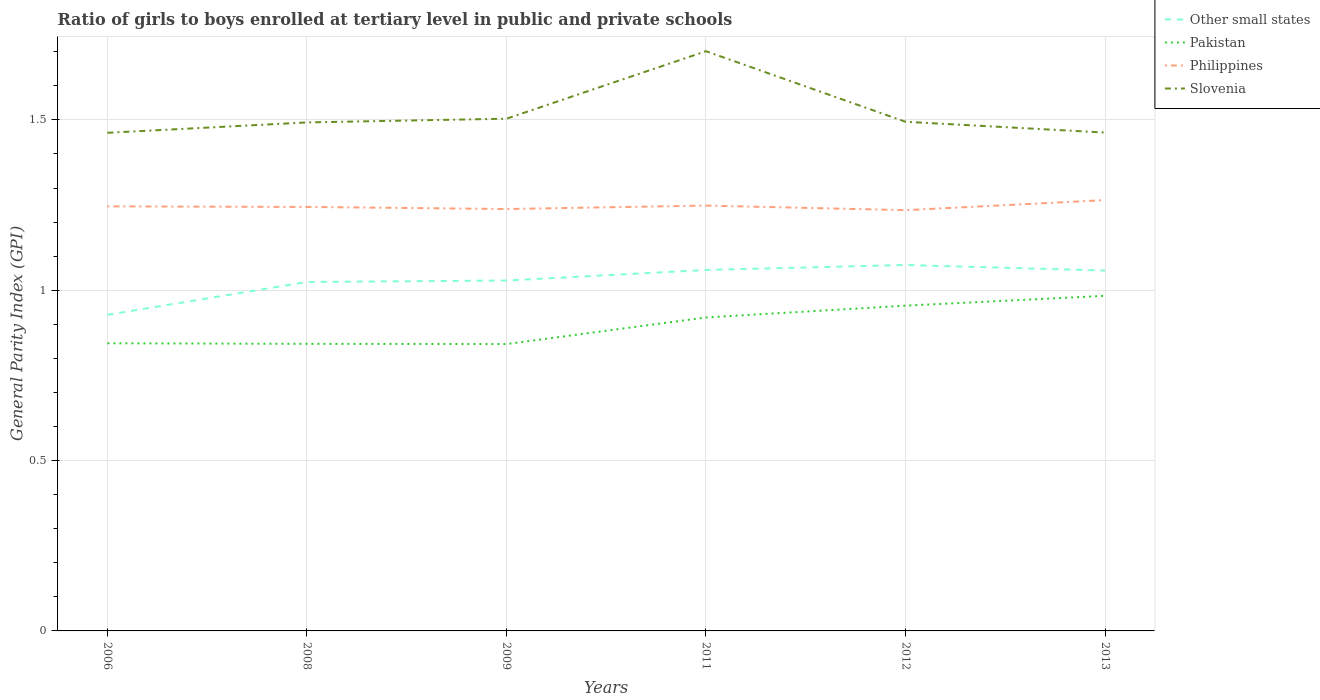How many different coloured lines are there?
Keep it short and to the point. 4. Does the line corresponding to Philippines intersect with the line corresponding to Other small states?
Keep it short and to the point. No. Is the number of lines equal to the number of legend labels?
Make the answer very short. Yes. Across all years, what is the maximum general parity index in Philippines?
Ensure brevity in your answer.  1.24. What is the total general parity index in Other small states in the graph?
Ensure brevity in your answer.  -0.15. What is the difference between the highest and the second highest general parity index in Other small states?
Provide a succinct answer. 0.15. Is the general parity index in Slovenia strictly greater than the general parity index in Philippines over the years?
Make the answer very short. No. How many lines are there?
Keep it short and to the point. 4. How many years are there in the graph?
Provide a short and direct response. 6. Are the values on the major ticks of Y-axis written in scientific E-notation?
Ensure brevity in your answer.  No. Where does the legend appear in the graph?
Keep it short and to the point. Top right. How many legend labels are there?
Provide a short and direct response. 4. What is the title of the graph?
Offer a very short reply. Ratio of girls to boys enrolled at tertiary level in public and private schools. What is the label or title of the X-axis?
Give a very brief answer. Years. What is the label or title of the Y-axis?
Make the answer very short. General Parity Index (GPI). What is the General Parity Index (GPI) of Other small states in 2006?
Your answer should be very brief. 0.93. What is the General Parity Index (GPI) of Pakistan in 2006?
Provide a short and direct response. 0.84. What is the General Parity Index (GPI) of Philippines in 2006?
Offer a terse response. 1.25. What is the General Parity Index (GPI) of Slovenia in 2006?
Your response must be concise. 1.46. What is the General Parity Index (GPI) of Other small states in 2008?
Offer a terse response. 1.02. What is the General Parity Index (GPI) in Pakistan in 2008?
Provide a succinct answer. 0.84. What is the General Parity Index (GPI) of Philippines in 2008?
Your response must be concise. 1.24. What is the General Parity Index (GPI) of Slovenia in 2008?
Provide a succinct answer. 1.49. What is the General Parity Index (GPI) in Other small states in 2009?
Give a very brief answer. 1.03. What is the General Parity Index (GPI) in Pakistan in 2009?
Keep it short and to the point. 0.84. What is the General Parity Index (GPI) in Philippines in 2009?
Offer a terse response. 1.24. What is the General Parity Index (GPI) of Slovenia in 2009?
Keep it short and to the point. 1.5. What is the General Parity Index (GPI) of Other small states in 2011?
Ensure brevity in your answer.  1.06. What is the General Parity Index (GPI) of Pakistan in 2011?
Your answer should be very brief. 0.92. What is the General Parity Index (GPI) of Philippines in 2011?
Your answer should be very brief. 1.25. What is the General Parity Index (GPI) of Slovenia in 2011?
Offer a very short reply. 1.7. What is the General Parity Index (GPI) of Other small states in 2012?
Offer a terse response. 1.07. What is the General Parity Index (GPI) in Pakistan in 2012?
Make the answer very short. 0.95. What is the General Parity Index (GPI) in Philippines in 2012?
Your answer should be very brief. 1.24. What is the General Parity Index (GPI) of Slovenia in 2012?
Offer a very short reply. 1.49. What is the General Parity Index (GPI) of Other small states in 2013?
Your answer should be very brief. 1.06. What is the General Parity Index (GPI) in Pakistan in 2013?
Offer a very short reply. 0.98. What is the General Parity Index (GPI) of Philippines in 2013?
Your answer should be very brief. 1.26. What is the General Parity Index (GPI) in Slovenia in 2013?
Your answer should be compact. 1.46. Across all years, what is the maximum General Parity Index (GPI) of Other small states?
Provide a succinct answer. 1.07. Across all years, what is the maximum General Parity Index (GPI) in Pakistan?
Offer a terse response. 0.98. Across all years, what is the maximum General Parity Index (GPI) in Philippines?
Provide a short and direct response. 1.26. Across all years, what is the maximum General Parity Index (GPI) in Slovenia?
Make the answer very short. 1.7. Across all years, what is the minimum General Parity Index (GPI) in Other small states?
Give a very brief answer. 0.93. Across all years, what is the minimum General Parity Index (GPI) of Pakistan?
Ensure brevity in your answer.  0.84. Across all years, what is the minimum General Parity Index (GPI) in Philippines?
Your answer should be very brief. 1.24. Across all years, what is the minimum General Parity Index (GPI) in Slovenia?
Offer a terse response. 1.46. What is the total General Parity Index (GPI) in Other small states in the graph?
Your answer should be compact. 6.17. What is the total General Parity Index (GPI) in Pakistan in the graph?
Offer a very short reply. 5.39. What is the total General Parity Index (GPI) of Philippines in the graph?
Your response must be concise. 7.48. What is the total General Parity Index (GPI) of Slovenia in the graph?
Keep it short and to the point. 9.12. What is the difference between the General Parity Index (GPI) in Other small states in 2006 and that in 2008?
Your answer should be very brief. -0.1. What is the difference between the General Parity Index (GPI) in Pakistan in 2006 and that in 2008?
Make the answer very short. 0. What is the difference between the General Parity Index (GPI) in Philippines in 2006 and that in 2008?
Provide a short and direct response. 0. What is the difference between the General Parity Index (GPI) of Slovenia in 2006 and that in 2008?
Ensure brevity in your answer.  -0.03. What is the difference between the General Parity Index (GPI) in Other small states in 2006 and that in 2009?
Provide a succinct answer. -0.1. What is the difference between the General Parity Index (GPI) in Pakistan in 2006 and that in 2009?
Provide a succinct answer. 0. What is the difference between the General Parity Index (GPI) of Philippines in 2006 and that in 2009?
Your answer should be very brief. 0.01. What is the difference between the General Parity Index (GPI) in Slovenia in 2006 and that in 2009?
Offer a very short reply. -0.04. What is the difference between the General Parity Index (GPI) of Other small states in 2006 and that in 2011?
Keep it short and to the point. -0.13. What is the difference between the General Parity Index (GPI) of Pakistan in 2006 and that in 2011?
Make the answer very short. -0.08. What is the difference between the General Parity Index (GPI) of Philippines in 2006 and that in 2011?
Offer a very short reply. -0. What is the difference between the General Parity Index (GPI) of Slovenia in 2006 and that in 2011?
Offer a terse response. -0.24. What is the difference between the General Parity Index (GPI) of Other small states in 2006 and that in 2012?
Provide a short and direct response. -0.15. What is the difference between the General Parity Index (GPI) of Pakistan in 2006 and that in 2012?
Ensure brevity in your answer.  -0.11. What is the difference between the General Parity Index (GPI) of Philippines in 2006 and that in 2012?
Provide a short and direct response. 0.01. What is the difference between the General Parity Index (GPI) of Slovenia in 2006 and that in 2012?
Your answer should be very brief. -0.03. What is the difference between the General Parity Index (GPI) of Other small states in 2006 and that in 2013?
Give a very brief answer. -0.13. What is the difference between the General Parity Index (GPI) of Pakistan in 2006 and that in 2013?
Provide a succinct answer. -0.14. What is the difference between the General Parity Index (GPI) in Philippines in 2006 and that in 2013?
Provide a short and direct response. -0.02. What is the difference between the General Parity Index (GPI) of Slovenia in 2006 and that in 2013?
Keep it short and to the point. -0. What is the difference between the General Parity Index (GPI) of Other small states in 2008 and that in 2009?
Your response must be concise. -0. What is the difference between the General Parity Index (GPI) of Pakistan in 2008 and that in 2009?
Your answer should be very brief. 0. What is the difference between the General Parity Index (GPI) in Philippines in 2008 and that in 2009?
Keep it short and to the point. 0.01. What is the difference between the General Parity Index (GPI) of Slovenia in 2008 and that in 2009?
Your response must be concise. -0.01. What is the difference between the General Parity Index (GPI) in Other small states in 2008 and that in 2011?
Offer a very short reply. -0.04. What is the difference between the General Parity Index (GPI) of Pakistan in 2008 and that in 2011?
Your response must be concise. -0.08. What is the difference between the General Parity Index (GPI) in Philippines in 2008 and that in 2011?
Provide a succinct answer. -0. What is the difference between the General Parity Index (GPI) of Slovenia in 2008 and that in 2011?
Your answer should be compact. -0.21. What is the difference between the General Parity Index (GPI) of Other small states in 2008 and that in 2012?
Provide a succinct answer. -0.05. What is the difference between the General Parity Index (GPI) of Pakistan in 2008 and that in 2012?
Your answer should be very brief. -0.11. What is the difference between the General Parity Index (GPI) in Philippines in 2008 and that in 2012?
Keep it short and to the point. 0.01. What is the difference between the General Parity Index (GPI) of Slovenia in 2008 and that in 2012?
Offer a terse response. -0. What is the difference between the General Parity Index (GPI) of Other small states in 2008 and that in 2013?
Your answer should be compact. -0.03. What is the difference between the General Parity Index (GPI) of Pakistan in 2008 and that in 2013?
Offer a terse response. -0.14. What is the difference between the General Parity Index (GPI) in Philippines in 2008 and that in 2013?
Your answer should be very brief. -0.02. What is the difference between the General Parity Index (GPI) in Slovenia in 2008 and that in 2013?
Offer a terse response. 0.03. What is the difference between the General Parity Index (GPI) of Other small states in 2009 and that in 2011?
Provide a short and direct response. -0.03. What is the difference between the General Parity Index (GPI) in Pakistan in 2009 and that in 2011?
Provide a short and direct response. -0.08. What is the difference between the General Parity Index (GPI) in Philippines in 2009 and that in 2011?
Ensure brevity in your answer.  -0.01. What is the difference between the General Parity Index (GPI) of Slovenia in 2009 and that in 2011?
Your answer should be very brief. -0.2. What is the difference between the General Parity Index (GPI) in Other small states in 2009 and that in 2012?
Offer a terse response. -0.05. What is the difference between the General Parity Index (GPI) of Pakistan in 2009 and that in 2012?
Keep it short and to the point. -0.11. What is the difference between the General Parity Index (GPI) in Philippines in 2009 and that in 2012?
Your response must be concise. 0. What is the difference between the General Parity Index (GPI) of Slovenia in 2009 and that in 2012?
Provide a short and direct response. 0.01. What is the difference between the General Parity Index (GPI) in Other small states in 2009 and that in 2013?
Give a very brief answer. -0.03. What is the difference between the General Parity Index (GPI) in Pakistan in 2009 and that in 2013?
Your answer should be very brief. -0.14. What is the difference between the General Parity Index (GPI) in Philippines in 2009 and that in 2013?
Offer a very short reply. -0.03. What is the difference between the General Parity Index (GPI) in Slovenia in 2009 and that in 2013?
Make the answer very short. 0.04. What is the difference between the General Parity Index (GPI) of Other small states in 2011 and that in 2012?
Offer a terse response. -0.01. What is the difference between the General Parity Index (GPI) of Pakistan in 2011 and that in 2012?
Your answer should be very brief. -0.03. What is the difference between the General Parity Index (GPI) in Philippines in 2011 and that in 2012?
Make the answer very short. 0.01. What is the difference between the General Parity Index (GPI) in Slovenia in 2011 and that in 2012?
Offer a terse response. 0.21. What is the difference between the General Parity Index (GPI) in Other small states in 2011 and that in 2013?
Your answer should be compact. 0. What is the difference between the General Parity Index (GPI) of Pakistan in 2011 and that in 2013?
Offer a very short reply. -0.06. What is the difference between the General Parity Index (GPI) in Philippines in 2011 and that in 2013?
Your response must be concise. -0.02. What is the difference between the General Parity Index (GPI) of Slovenia in 2011 and that in 2013?
Provide a succinct answer. 0.24. What is the difference between the General Parity Index (GPI) of Other small states in 2012 and that in 2013?
Provide a short and direct response. 0.02. What is the difference between the General Parity Index (GPI) of Pakistan in 2012 and that in 2013?
Make the answer very short. -0.03. What is the difference between the General Parity Index (GPI) of Philippines in 2012 and that in 2013?
Provide a succinct answer. -0.03. What is the difference between the General Parity Index (GPI) of Slovenia in 2012 and that in 2013?
Provide a short and direct response. 0.03. What is the difference between the General Parity Index (GPI) of Other small states in 2006 and the General Parity Index (GPI) of Pakistan in 2008?
Provide a short and direct response. 0.09. What is the difference between the General Parity Index (GPI) in Other small states in 2006 and the General Parity Index (GPI) in Philippines in 2008?
Offer a very short reply. -0.32. What is the difference between the General Parity Index (GPI) of Other small states in 2006 and the General Parity Index (GPI) of Slovenia in 2008?
Provide a short and direct response. -0.56. What is the difference between the General Parity Index (GPI) of Pakistan in 2006 and the General Parity Index (GPI) of Philippines in 2008?
Your response must be concise. -0.4. What is the difference between the General Parity Index (GPI) in Pakistan in 2006 and the General Parity Index (GPI) in Slovenia in 2008?
Your response must be concise. -0.65. What is the difference between the General Parity Index (GPI) in Philippines in 2006 and the General Parity Index (GPI) in Slovenia in 2008?
Give a very brief answer. -0.25. What is the difference between the General Parity Index (GPI) of Other small states in 2006 and the General Parity Index (GPI) of Pakistan in 2009?
Make the answer very short. 0.09. What is the difference between the General Parity Index (GPI) in Other small states in 2006 and the General Parity Index (GPI) in Philippines in 2009?
Your answer should be very brief. -0.31. What is the difference between the General Parity Index (GPI) in Other small states in 2006 and the General Parity Index (GPI) in Slovenia in 2009?
Offer a very short reply. -0.58. What is the difference between the General Parity Index (GPI) in Pakistan in 2006 and the General Parity Index (GPI) in Philippines in 2009?
Your answer should be very brief. -0.39. What is the difference between the General Parity Index (GPI) in Pakistan in 2006 and the General Parity Index (GPI) in Slovenia in 2009?
Your answer should be very brief. -0.66. What is the difference between the General Parity Index (GPI) of Philippines in 2006 and the General Parity Index (GPI) of Slovenia in 2009?
Provide a succinct answer. -0.26. What is the difference between the General Parity Index (GPI) in Other small states in 2006 and the General Parity Index (GPI) in Pakistan in 2011?
Offer a terse response. 0.01. What is the difference between the General Parity Index (GPI) of Other small states in 2006 and the General Parity Index (GPI) of Philippines in 2011?
Your answer should be very brief. -0.32. What is the difference between the General Parity Index (GPI) of Other small states in 2006 and the General Parity Index (GPI) of Slovenia in 2011?
Offer a very short reply. -0.77. What is the difference between the General Parity Index (GPI) in Pakistan in 2006 and the General Parity Index (GPI) in Philippines in 2011?
Your response must be concise. -0.4. What is the difference between the General Parity Index (GPI) in Pakistan in 2006 and the General Parity Index (GPI) in Slovenia in 2011?
Offer a terse response. -0.86. What is the difference between the General Parity Index (GPI) in Philippines in 2006 and the General Parity Index (GPI) in Slovenia in 2011?
Offer a very short reply. -0.46. What is the difference between the General Parity Index (GPI) in Other small states in 2006 and the General Parity Index (GPI) in Pakistan in 2012?
Offer a terse response. -0.03. What is the difference between the General Parity Index (GPI) in Other small states in 2006 and the General Parity Index (GPI) in Philippines in 2012?
Keep it short and to the point. -0.31. What is the difference between the General Parity Index (GPI) in Other small states in 2006 and the General Parity Index (GPI) in Slovenia in 2012?
Give a very brief answer. -0.57. What is the difference between the General Parity Index (GPI) in Pakistan in 2006 and the General Parity Index (GPI) in Philippines in 2012?
Your response must be concise. -0.39. What is the difference between the General Parity Index (GPI) in Pakistan in 2006 and the General Parity Index (GPI) in Slovenia in 2012?
Keep it short and to the point. -0.65. What is the difference between the General Parity Index (GPI) in Philippines in 2006 and the General Parity Index (GPI) in Slovenia in 2012?
Your answer should be very brief. -0.25. What is the difference between the General Parity Index (GPI) of Other small states in 2006 and the General Parity Index (GPI) of Pakistan in 2013?
Make the answer very short. -0.06. What is the difference between the General Parity Index (GPI) in Other small states in 2006 and the General Parity Index (GPI) in Philippines in 2013?
Your response must be concise. -0.34. What is the difference between the General Parity Index (GPI) in Other small states in 2006 and the General Parity Index (GPI) in Slovenia in 2013?
Provide a succinct answer. -0.53. What is the difference between the General Parity Index (GPI) of Pakistan in 2006 and the General Parity Index (GPI) of Philippines in 2013?
Give a very brief answer. -0.42. What is the difference between the General Parity Index (GPI) of Pakistan in 2006 and the General Parity Index (GPI) of Slovenia in 2013?
Keep it short and to the point. -0.62. What is the difference between the General Parity Index (GPI) of Philippines in 2006 and the General Parity Index (GPI) of Slovenia in 2013?
Keep it short and to the point. -0.22. What is the difference between the General Parity Index (GPI) in Other small states in 2008 and the General Parity Index (GPI) in Pakistan in 2009?
Offer a terse response. 0.18. What is the difference between the General Parity Index (GPI) in Other small states in 2008 and the General Parity Index (GPI) in Philippines in 2009?
Make the answer very short. -0.21. What is the difference between the General Parity Index (GPI) of Other small states in 2008 and the General Parity Index (GPI) of Slovenia in 2009?
Keep it short and to the point. -0.48. What is the difference between the General Parity Index (GPI) in Pakistan in 2008 and the General Parity Index (GPI) in Philippines in 2009?
Ensure brevity in your answer.  -0.4. What is the difference between the General Parity Index (GPI) of Pakistan in 2008 and the General Parity Index (GPI) of Slovenia in 2009?
Provide a succinct answer. -0.66. What is the difference between the General Parity Index (GPI) in Philippines in 2008 and the General Parity Index (GPI) in Slovenia in 2009?
Ensure brevity in your answer.  -0.26. What is the difference between the General Parity Index (GPI) of Other small states in 2008 and the General Parity Index (GPI) of Pakistan in 2011?
Your response must be concise. 0.1. What is the difference between the General Parity Index (GPI) in Other small states in 2008 and the General Parity Index (GPI) in Philippines in 2011?
Provide a succinct answer. -0.22. What is the difference between the General Parity Index (GPI) in Other small states in 2008 and the General Parity Index (GPI) in Slovenia in 2011?
Provide a short and direct response. -0.68. What is the difference between the General Parity Index (GPI) in Pakistan in 2008 and the General Parity Index (GPI) in Philippines in 2011?
Give a very brief answer. -0.41. What is the difference between the General Parity Index (GPI) of Pakistan in 2008 and the General Parity Index (GPI) of Slovenia in 2011?
Offer a terse response. -0.86. What is the difference between the General Parity Index (GPI) in Philippines in 2008 and the General Parity Index (GPI) in Slovenia in 2011?
Ensure brevity in your answer.  -0.46. What is the difference between the General Parity Index (GPI) of Other small states in 2008 and the General Parity Index (GPI) of Pakistan in 2012?
Your response must be concise. 0.07. What is the difference between the General Parity Index (GPI) in Other small states in 2008 and the General Parity Index (GPI) in Philippines in 2012?
Provide a succinct answer. -0.21. What is the difference between the General Parity Index (GPI) of Other small states in 2008 and the General Parity Index (GPI) of Slovenia in 2012?
Your response must be concise. -0.47. What is the difference between the General Parity Index (GPI) of Pakistan in 2008 and the General Parity Index (GPI) of Philippines in 2012?
Offer a very short reply. -0.39. What is the difference between the General Parity Index (GPI) in Pakistan in 2008 and the General Parity Index (GPI) in Slovenia in 2012?
Ensure brevity in your answer.  -0.65. What is the difference between the General Parity Index (GPI) of Philippines in 2008 and the General Parity Index (GPI) of Slovenia in 2012?
Offer a terse response. -0.25. What is the difference between the General Parity Index (GPI) in Other small states in 2008 and the General Parity Index (GPI) in Pakistan in 2013?
Ensure brevity in your answer.  0.04. What is the difference between the General Parity Index (GPI) of Other small states in 2008 and the General Parity Index (GPI) of Philippines in 2013?
Make the answer very short. -0.24. What is the difference between the General Parity Index (GPI) of Other small states in 2008 and the General Parity Index (GPI) of Slovenia in 2013?
Ensure brevity in your answer.  -0.44. What is the difference between the General Parity Index (GPI) of Pakistan in 2008 and the General Parity Index (GPI) of Philippines in 2013?
Your answer should be compact. -0.42. What is the difference between the General Parity Index (GPI) of Pakistan in 2008 and the General Parity Index (GPI) of Slovenia in 2013?
Offer a terse response. -0.62. What is the difference between the General Parity Index (GPI) of Philippines in 2008 and the General Parity Index (GPI) of Slovenia in 2013?
Your response must be concise. -0.22. What is the difference between the General Parity Index (GPI) of Other small states in 2009 and the General Parity Index (GPI) of Pakistan in 2011?
Provide a succinct answer. 0.11. What is the difference between the General Parity Index (GPI) in Other small states in 2009 and the General Parity Index (GPI) in Philippines in 2011?
Offer a terse response. -0.22. What is the difference between the General Parity Index (GPI) of Other small states in 2009 and the General Parity Index (GPI) of Slovenia in 2011?
Give a very brief answer. -0.67. What is the difference between the General Parity Index (GPI) in Pakistan in 2009 and the General Parity Index (GPI) in Philippines in 2011?
Keep it short and to the point. -0.41. What is the difference between the General Parity Index (GPI) of Pakistan in 2009 and the General Parity Index (GPI) of Slovenia in 2011?
Keep it short and to the point. -0.86. What is the difference between the General Parity Index (GPI) of Philippines in 2009 and the General Parity Index (GPI) of Slovenia in 2011?
Give a very brief answer. -0.46. What is the difference between the General Parity Index (GPI) in Other small states in 2009 and the General Parity Index (GPI) in Pakistan in 2012?
Keep it short and to the point. 0.07. What is the difference between the General Parity Index (GPI) in Other small states in 2009 and the General Parity Index (GPI) in Philippines in 2012?
Your answer should be compact. -0.21. What is the difference between the General Parity Index (GPI) of Other small states in 2009 and the General Parity Index (GPI) of Slovenia in 2012?
Your answer should be very brief. -0.47. What is the difference between the General Parity Index (GPI) of Pakistan in 2009 and the General Parity Index (GPI) of Philippines in 2012?
Keep it short and to the point. -0.39. What is the difference between the General Parity Index (GPI) in Pakistan in 2009 and the General Parity Index (GPI) in Slovenia in 2012?
Ensure brevity in your answer.  -0.65. What is the difference between the General Parity Index (GPI) in Philippines in 2009 and the General Parity Index (GPI) in Slovenia in 2012?
Your answer should be very brief. -0.26. What is the difference between the General Parity Index (GPI) in Other small states in 2009 and the General Parity Index (GPI) in Pakistan in 2013?
Offer a terse response. 0.04. What is the difference between the General Parity Index (GPI) of Other small states in 2009 and the General Parity Index (GPI) of Philippines in 2013?
Ensure brevity in your answer.  -0.24. What is the difference between the General Parity Index (GPI) of Other small states in 2009 and the General Parity Index (GPI) of Slovenia in 2013?
Your answer should be compact. -0.43. What is the difference between the General Parity Index (GPI) in Pakistan in 2009 and the General Parity Index (GPI) in Philippines in 2013?
Make the answer very short. -0.42. What is the difference between the General Parity Index (GPI) in Pakistan in 2009 and the General Parity Index (GPI) in Slovenia in 2013?
Keep it short and to the point. -0.62. What is the difference between the General Parity Index (GPI) of Philippines in 2009 and the General Parity Index (GPI) of Slovenia in 2013?
Your answer should be compact. -0.22. What is the difference between the General Parity Index (GPI) of Other small states in 2011 and the General Parity Index (GPI) of Pakistan in 2012?
Keep it short and to the point. 0.1. What is the difference between the General Parity Index (GPI) of Other small states in 2011 and the General Parity Index (GPI) of Philippines in 2012?
Give a very brief answer. -0.18. What is the difference between the General Parity Index (GPI) in Other small states in 2011 and the General Parity Index (GPI) in Slovenia in 2012?
Keep it short and to the point. -0.43. What is the difference between the General Parity Index (GPI) of Pakistan in 2011 and the General Parity Index (GPI) of Philippines in 2012?
Offer a terse response. -0.31. What is the difference between the General Parity Index (GPI) in Pakistan in 2011 and the General Parity Index (GPI) in Slovenia in 2012?
Give a very brief answer. -0.57. What is the difference between the General Parity Index (GPI) of Philippines in 2011 and the General Parity Index (GPI) of Slovenia in 2012?
Ensure brevity in your answer.  -0.25. What is the difference between the General Parity Index (GPI) of Other small states in 2011 and the General Parity Index (GPI) of Pakistan in 2013?
Make the answer very short. 0.08. What is the difference between the General Parity Index (GPI) of Other small states in 2011 and the General Parity Index (GPI) of Philippines in 2013?
Provide a succinct answer. -0.2. What is the difference between the General Parity Index (GPI) of Other small states in 2011 and the General Parity Index (GPI) of Slovenia in 2013?
Offer a terse response. -0.4. What is the difference between the General Parity Index (GPI) in Pakistan in 2011 and the General Parity Index (GPI) in Philippines in 2013?
Provide a short and direct response. -0.34. What is the difference between the General Parity Index (GPI) of Pakistan in 2011 and the General Parity Index (GPI) of Slovenia in 2013?
Your answer should be compact. -0.54. What is the difference between the General Parity Index (GPI) of Philippines in 2011 and the General Parity Index (GPI) of Slovenia in 2013?
Offer a very short reply. -0.21. What is the difference between the General Parity Index (GPI) in Other small states in 2012 and the General Parity Index (GPI) in Pakistan in 2013?
Offer a terse response. 0.09. What is the difference between the General Parity Index (GPI) in Other small states in 2012 and the General Parity Index (GPI) in Philippines in 2013?
Keep it short and to the point. -0.19. What is the difference between the General Parity Index (GPI) in Other small states in 2012 and the General Parity Index (GPI) in Slovenia in 2013?
Offer a terse response. -0.39. What is the difference between the General Parity Index (GPI) in Pakistan in 2012 and the General Parity Index (GPI) in Philippines in 2013?
Give a very brief answer. -0.31. What is the difference between the General Parity Index (GPI) in Pakistan in 2012 and the General Parity Index (GPI) in Slovenia in 2013?
Give a very brief answer. -0.51. What is the difference between the General Parity Index (GPI) of Philippines in 2012 and the General Parity Index (GPI) of Slovenia in 2013?
Your response must be concise. -0.23. What is the average General Parity Index (GPI) in Other small states per year?
Offer a very short reply. 1.03. What is the average General Parity Index (GPI) in Pakistan per year?
Your response must be concise. 0.9. What is the average General Parity Index (GPI) of Philippines per year?
Provide a succinct answer. 1.25. What is the average General Parity Index (GPI) in Slovenia per year?
Your answer should be very brief. 1.52. In the year 2006, what is the difference between the General Parity Index (GPI) in Other small states and General Parity Index (GPI) in Pakistan?
Give a very brief answer. 0.08. In the year 2006, what is the difference between the General Parity Index (GPI) in Other small states and General Parity Index (GPI) in Philippines?
Offer a very short reply. -0.32. In the year 2006, what is the difference between the General Parity Index (GPI) in Other small states and General Parity Index (GPI) in Slovenia?
Provide a succinct answer. -0.53. In the year 2006, what is the difference between the General Parity Index (GPI) of Pakistan and General Parity Index (GPI) of Philippines?
Give a very brief answer. -0.4. In the year 2006, what is the difference between the General Parity Index (GPI) in Pakistan and General Parity Index (GPI) in Slovenia?
Offer a very short reply. -0.62. In the year 2006, what is the difference between the General Parity Index (GPI) in Philippines and General Parity Index (GPI) in Slovenia?
Keep it short and to the point. -0.22. In the year 2008, what is the difference between the General Parity Index (GPI) in Other small states and General Parity Index (GPI) in Pakistan?
Offer a terse response. 0.18. In the year 2008, what is the difference between the General Parity Index (GPI) of Other small states and General Parity Index (GPI) of Philippines?
Ensure brevity in your answer.  -0.22. In the year 2008, what is the difference between the General Parity Index (GPI) in Other small states and General Parity Index (GPI) in Slovenia?
Provide a succinct answer. -0.47. In the year 2008, what is the difference between the General Parity Index (GPI) in Pakistan and General Parity Index (GPI) in Philippines?
Offer a very short reply. -0.4. In the year 2008, what is the difference between the General Parity Index (GPI) in Pakistan and General Parity Index (GPI) in Slovenia?
Keep it short and to the point. -0.65. In the year 2008, what is the difference between the General Parity Index (GPI) in Philippines and General Parity Index (GPI) in Slovenia?
Offer a terse response. -0.25. In the year 2009, what is the difference between the General Parity Index (GPI) in Other small states and General Parity Index (GPI) in Pakistan?
Ensure brevity in your answer.  0.19. In the year 2009, what is the difference between the General Parity Index (GPI) of Other small states and General Parity Index (GPI) of Philippines?
Provide a short and direct response. -0.21. In the year 2009, what is the difference between the General Parity Index (GPI) of Other small states and General Parity Index (GPI) of Slovenia?
Offer a very short reply. -0.47. In the year 2009, what is the difference between the General Parity Index (GPI) of Pakistan and General Parity Index (GPI) of Philippines?
Keep it short and to the point. -0.4. In the year 2009, what is the difference between the General Parity Index (GPI) of Pakistan and General Parity Index (GPI) of Slovenia?
Keep it short and to the point. -0.66. In the year 2009, what is the difference between the General Parity Index (GPI) of Philippines and General Parity Index (GPI) of Slovenia?
Provide a succinct answer. -0.27. In the year 2011, what is the difference between the General Parity Index (GPI) in Other small states and General Parity Index (GPI) in Pakistan?
Your answer should be very brief. 0.14. In the year 2011, what is the difference between the General Parity Index (GPI) of Other small states and General Parity Index (GPI) of Philippines?
Your answer should be very brief. -0.19. In the year 2011, what is the difference between the General Parity Index (GPI) in Other small states and General Parity Index (GPI) in Slovenia?
Provide a succinct answer. -0.64. In the year 2011, what is the difference between the General Parity Index (GPI) of Pakistan and General Parity Index (GPI) of Philippines?
Your answer should be compact. -0.33. In the year 2011, what is the difference between the General Parity Index (GPI) in Pakistan and General Parity Index (GPI) in Slovenia?
Your answer should be compact. -0.78. In the year 2011, what is the difference between the General Parity Index (GPI) of Philippines and General Parity Index (GPI) of Slovenia?
Offer a terse response. -0.45. In the year 2012, what is the difference between the General Parity Index (GPI) of Other small states and General Parity Index (GPI) of Pakistan?
Offer a very short reply. 0.12. In the year 2012, what is the difference between the General Parity Index (GPI) of Other small states and General Parity Index (GPI) of Philippines?
Your answer should be compact. -0.16. In the year 2012, what is the difference between the General Parity Index (GPI) of Other small states and General Parity Index (GPI) of Slovenia?
Ensure brevity in your answer.  -0.42. In the year 2012, what is the difference between the General Parity Index (GPI) in Pakistan and General Parity Index (GPI) in Philippines?
Keep it short and to the point. -0.28. In the year 2012, what is the difference between the General Parity Index (GPI) in Pakistan and General Parity Index (GPI) in Slovenia?
Your answer should be compact. -0.54. In the year 2012, what is the difference between the General Parity Index (GPI) in Philippines and General Parity Index (GPI) in Slovenia?
Your response must be concise. -0.26. In the year 2013, what is the difference between the General Parity Index (GPI) in Other small states and General Parity Index (GPI) in Pakistan?
Ensure brevity in your answer.  0.07. In the year 2013, what is the difference between the General Parity Index (GPI) of Other small states and General Parity Index (GPI) of Philippines?
Offer a very short reply. -0.21. In the year 2013, what is the difference between the General Parity Index (GPI) in Other small states and General Parity Index (GPI) in Slovenia?
Provide a succinct answer. -0.4. In the year 2013, what is the difference between the General Parity Index (GPI) in Pakistan and General Parity Index (GPI) in Philippines?
Provide a short and direct response. -0.28. In the year 2013, what is the difference between the General Parity Index (GPI) of Pakistan and General Parity Index (GPI) of Slovenia?
Your response must be concise. -0.48. In the year 2013, what is the difference between the General Parity Index (GPI) in Philippines and General Parity Index (GPI) in Slovenia?
Offer a terse response. -0.2. What is the ratio of the General Parity Index (GPI) of Other small states in 2006 to that in 2008?
Provide a succinct answer. 0.91. What is the ratio of the General Parity Index (GPI) in Philippines in 2006 to that in 2008?
Provide a short and direct response. 1. What is the ratio of the General Parity Index (GPI) in Slovenia in 2006 to that in 2008?
Make the answer very short. 0.98. What is the ratio of the General Parity Index (GPI) of Other small states in 2006 to that in 2009?
Ensure brevity in your answer.  0.9. What is the ratio of the General Parity Index (GPI) in Pakistan in 2006 to that in 2009?
Your answer should be very brief. 1. What is the ratio of the General Parity Index (GPI) in Slovenia in 2006 to that in 2009?
Your answer should be very brief. 0.97. What is the ratio of the General Parity Index (GPI) of Other small states in 2006 to that in 2011?
Provide a succinct answer. 0.88. What is the ratio of the General Parity Index (GPI) of Pakistan in 2006 to that in 2011?
Your answer should be very brief. 0.92. What is the ratio of the General Parity Index (GPI) of Slovenia in 2006 to that in 2011?
Ensure brevity in your answer.  0.86. What is the ratio of the General Parity Index (GPI) in Other small states in 2006 to that in 2012?
Your answer should be very brief. 0.86. What is the ratio of the General Parity Index (GPI) of Pakistan in 2006 to that in 2012?
Your answer should be very brief. 0.88. What is the ratio of the General Parity Index (GPI) of Slovenia in 2006 to that in 2012?
Offer a terse response. 0.98. What is the ratio of the General Parity Index (GPI) in Other small states in 2006 to that in 2013?
Your answer should be compact. 0.88. What is the ratio of the General Parity Index (GPI) in Pakistan in 2006 to that in 2013?
Offer a very short reply. 0.86. What is the ratio of the General Parity Index (GPI) of Philippines in 2006 to that in 2013?
Your answer should be compact. 0.99. What is the ratio of the General Parity Index (GPI) in Other small states in 2008 to that in 2009?
Provide a succinct answer. 1. What is the ratio of the General Parity Index (GPI) in Pakistan in 2008 to that in 2009?
Your answer should be very brief. 1. What is the ratio of the General Parity Index (GPI) of Philippines in 2008 to that in 2009?
Provide a short and direct response. 1. What is the ratio of the General Parity Index (GPI) of Other small states in 2008 to that in 2011?
Ensure brevity in your answer.  0.97. What is the ratio of the General Parity Index (GPI) in Pakistan in 2008 to that in 2011?
Provide a short and direct response. 0.92. What is the ratio of the General Parity Index (GPI) in Philippines in 2008 to that in 2011?
Offer a terse response. 1. What is the ratio of the General Parity Index (GPI) of Slovenia in 2008 to that in 2011?
Offer a terse response. 0.88. What is the ratio of the General Parity Index (GPI) of Other small states in 2008 to that in 2012?
Provide a succinct answer. 0.95. What is the ratio of the General Parity Index (GPI) of Pakistan in 2008 to that in 2012?
Your response must be concise. 0.88. What is the ratio of the General Parity Index (GPI) of Philippines in 2008 to that in 2012?
Provide a succinct answer. 1.01. What is the ratio of the General Parity Index (GPI) in Slovenia in 2008 to that in 2012?
Your response must be concise. 1. What is the ratio of the General Parity Index (GPI) in Other small states in 2008 to that in 2013?
Offer a very short reply. 0.97. What is the ratio of the General Parity Index (GPI) of Pakistan in 2008 to that in 2013?
Provide a short and direct response. 0.86. What is the ratio of the General Parity Index (GPI) of Philippines in 2008 to that in 2013?
Give a very brief answer. 0.98. What is the ratio of the General Parity Index (GPI) in Slovenia in 2008 to that in 2013?
Your answer should be compact. 1.02. What is the ratio of the General Parity Index (GPI) in Other small states in 2009 to that in 2011?
Provide a short and direct response. 0.97. What is the ratio of the General Parity Index (GPI) in Pakistan in 2009 to that in 2011?
Your answer should be very brief. 0.92. What is the ratio of the General Parity Index (GPI) in Slovenia in 2009 to that in 2011?
Your answer should be compact. 0.88. What is the ratio of the General Parity Index (GPI) in Other small states in 2009 to that in 2012?
Your answer should be compact. 0.96. What is the ratio of the General Parity Index (GPI) in Pakistan in 2009 to that in 2012?
Keep it short and to the point. 0.88. What is the ratio of the General Parity Index (GPI) of Other small states in 2009 to that in 2013?
Provide a short and direct response. 0.97. What is the ratio of the General Parity Index (GPI) of Pakistan in 2009 to that in 2013?
Provide a succinct answer. 0.86. What is the ratio of the General Parity Index (GPI) of Philippines in 2009 to that in 2013?
Keep it short and to the point. 0.98. What is the ratio of the General Parity Index (GPI) in Slovenia in 2009 to that in 2013?
Keep it short and to the point. 1.03. What is the ratio of the General Parity Index (GPI) in Other small states in 2011 to that in 2012?
Your answer should be very brief. 0.99. What is the ratio of the General Parity Index (GPI) of Pakistan in 2011 to that in 2012?
Keep it short and to the point. 0.96. What is the ratio of the General Parity Index (GPI) of Philippines in 2011 to that in 2012?
Keep it short and to the point. 1.01. What is the ratio of the General Parity Index (GPI) of Slovenia in 2011 to that in 2012?
Offer a terse response. 1.14. What is the ratio of the General Parity Index (GPI) of Other small states in 2011 to that in 2013?
Your response must be concise. 1. What is the ratio of the General Parity Index (GPI) in Pakistan in 2011 to that in 2013?
Your response must be concise. 0.94. What is the ratio of the General Parity Index (GPI) in Philippines in 2011 to that in 2013?
Your answer should be very brief. 0.99. What is the ratio of the General Parity Index (GPI) in Slovenia in 2011 to that in 2013?
Keep it short and to the point. 1.16. What is the ratio of the General Parity Index (GPI) in Other small states in 2012 to that in 2013?
Offer a terse response. 1.02. What is the ratio of the General Parity Index (GPI) in Pakistan in 2012 to that in 2013?
Your response must be concise. 0.97. What is the ratio of the General Parity Index (GPI) in Philippines in 2012 to that in 2013?
Your answer should be compact. 0.98. What is the ratio of the General Parity Index (GPI) in Slovenia in 2012 to that in 2013?
Offer a very short reply. 1.02. What is the difference between the highest and the second highest General Parity Index (GPI) in Other small states?
Keep it short and to the point. 0.01. What is the difference between the highest and the second highest General Parity Index (GPI) of Pakistan?
Keep it short and to the point. 0.03. What is the difference between the highest and the second highest General Parity Index (GPI) in Philippines?
Provide a succinct answer. 0.02. What is the difference between the highest and the second highest General Parity Index (GPI) of Slovenia?
Your response must be concise. 0.2. What is the difference between the highest and the lowest General Parity Index (GPI) in Other small states?
Keep it short and to the point. 0.15. What is the difference between the highest and the lowest General Parity Index (GPI) of Pakistan?
Offer a terse response. 0.14. What is the difference between the highest and the lowest General Parity Index (GPI) in Philippines?
Keep it short and to the point. 0.03. What is the difference between the highest and the lowest General Parity Index (GPI) in Slovenia?
Give a very brief answer. 0.24. 